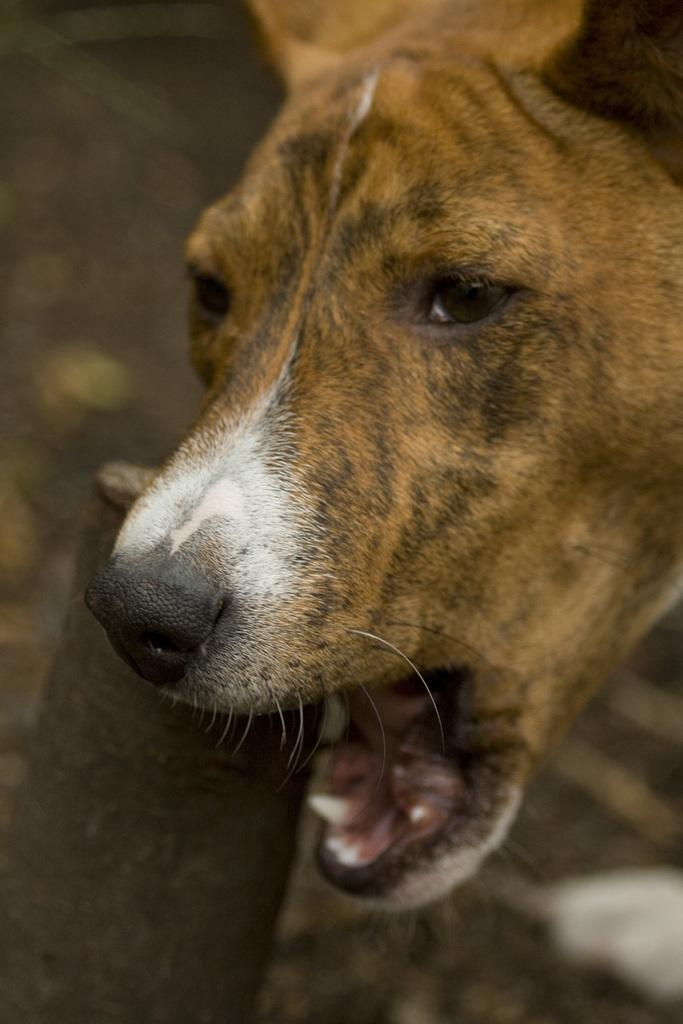What type of animal is in the image? There is a dog in the image. What can be seen in the background of the image? The background of the image includes the ground. How would you describe the background of the image? The background appears blurry. How many thumbs does the dog have in the image? Dogs do not have thumbs, so this question cannot be answered based on the image. 